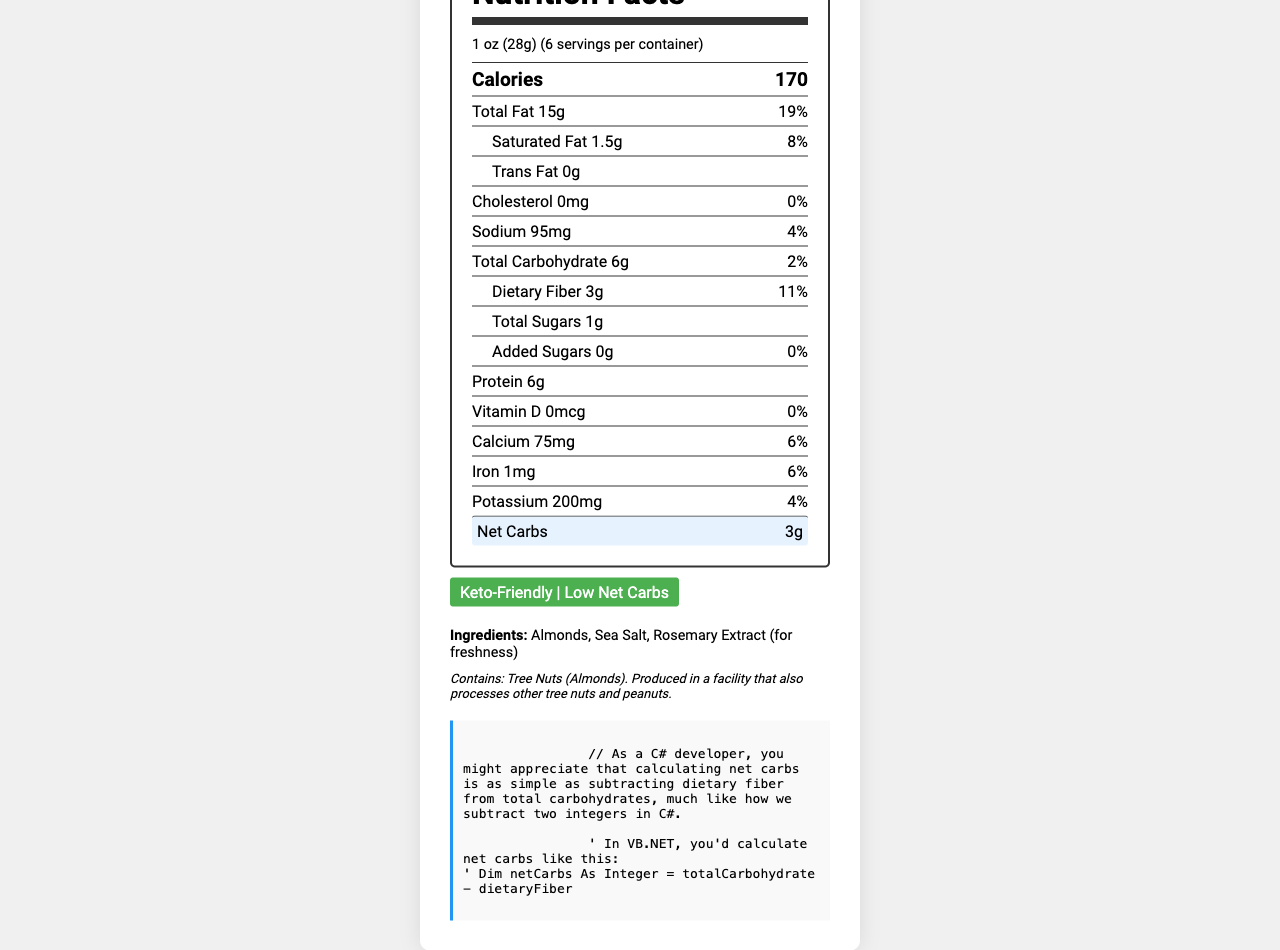what is the serving size of Keto Crunch Almonds? The serving size is mentioned at the top of the label under the serving info.
Answer: 1 oz (28g) how many calories are in one serving? The calories per serving are listed as 170 in the macro section of the label.
Answer: 170 how much total fat is in one serving? The total fat per serving is mentioned as 15g with a daily value of 19%.
Answer: 15g what is the amount of dietary fiber per serving? The dietary fiber amount is listed under the carbohydrate section as 3g with a daily value of 11%.
Answer: 3g what is the net carb content per serving? The net carbs are highlighted separately at the bottom of the macro section with a value of 3g.
Answer: 3g what is the daily value percentage for saturated fat? The daily value percentage for saturated fat is listed as 8% right after the amount in grams.
Answer: 8% which of the following ingredients is used for freshness? A. Sea Salt B. Almonds C. Rosemary Extract The ingredients section lists "Rosemary Extract (for freshness)".
Answer: C. Rosemary Extract how much sodium is in one serving? A. 75mg B. 95mg C. 200mg The sodium content per serving is listed as 95mg with a daily value of 4%.
Answer: B. 95mg is this product keto-friendly? The document clearly states "Keto-Friendly" in the keto label section.
Answer: Yes what is the daily value percentage for iron? The daily value for iron is listed in the nutrition facts as 6%.
Answer: 6% does this product contain any added sugars? The document states that added sugars are 0g with a daily value of 0%.
Answer: No which nutrient has the highest daily value percentage? A. Total Fat B. Dietary Fiber C. Sodium Total Fat has a daily value of 19%, which is the highest among the listed nutrients.
Answer: A. Total Fat what allergens are present in Keto Crunch Almonds? The allergen information section indicates that the product contains tree nuts (almonds).
Answer: Tree Nuts (Almonds) cannot be determined - what is the manufacturing date of the product? The manufacturing date is not mentioned anywhere in the visual information of the document.
Answer: Cannot be determined summarize the main purpose of the document The entire document delivers a comprehensive overview of the nutritional facts, affirming it as a suitable snack for keto dieters and those seeking low net carbs. It also lists the ingredients and allergen warning, which are important for consumers.
Answer: The document provides detailed nutritional information about the Keto Crunch Almonds, highlighting its keto-friendly and low-carb nature. It includes serving size, calorie count, macronutrient and micronutrient content, ingredients, and allergen information. 